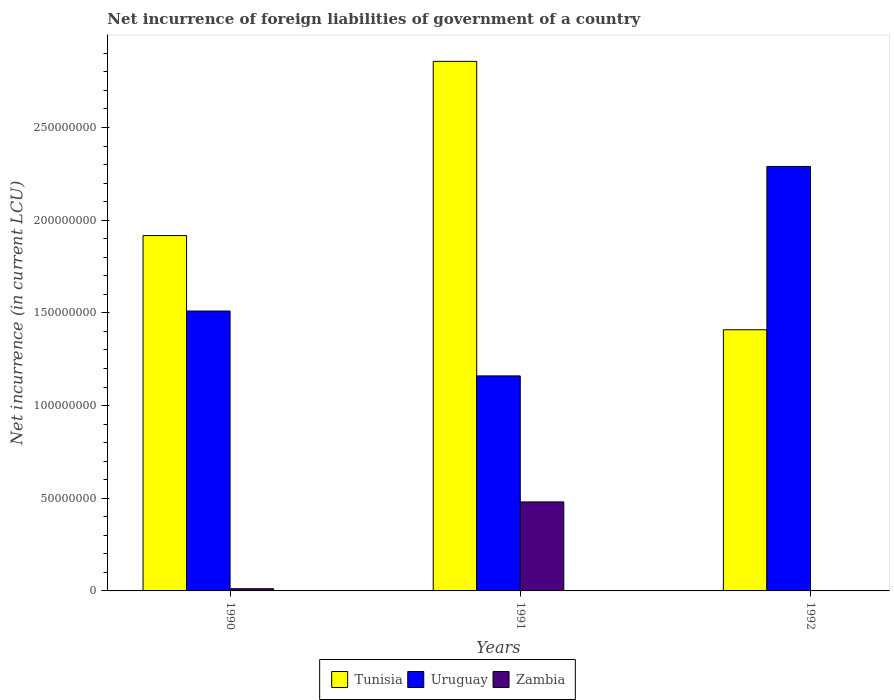How many different coloured bars are there?
Provide a succinct answer. 3. How many groups of bars are there?
Ensure brevity in your answer.  3. Are the number of bars on each tick of the X-axis equal?
Keep it short and to the point. Yes. How many bars are there on the 1st tick from the right?
Offer a terse response. 3. What is the net incurrence of foreign liabilities in Tunisia in 1992?
Provide a short and direct response. 1.41e+08. Across all years, what is the maximum net incurrence of foreign liabilities in Zambia?
Provide a succinct answer. 4.80e+07. Across all years, what is the minimum net incurrence of foreign liabilities in Uruguay?
Offer a terse response. 1.16e+08. What is the total net incurrence of foreign liabilities in Zambia in the graph?
Ensure brevity in your answer.  4.93e+07. What is the difference between the net incurrence of foreign liabilities in Tunisia in 1990 and that in 1992?
Your answer should be very brief. 5.08e+07. What is the difference between the net incurrence of foreign liabilities in Uruguay in 1992 and the net incurrence of foreign liabilities in Tunisia in 1991?
Ensure brevity in your answer.  -5.67e+07. What is the average net incurrence of foreign liabilities in Tunisia per year?
Your answer should be compact. 2.06e+08. In the year 1992, what is the difference between the net incurrence of foreign liabilities in Tunisia and net incurrence of foreign liabilities in Zambia?
Give a very brief answer. 1.41e+08. In how many years, is the net incurrence of foreign liabilities in Tunisia greater than 210000000 LCU?
Provide a short and direct response. 1. What is the ratio of the net incurrence of foreign liabilities in Uruguay in 1990 to that in 1992?
Provide a succinct answer. 0.66. What is the difference between the highest and the second highest net incurrence of foreign liabilities in Tunisia?
Make the answer very short. 9.40e+07. What is the difference between the highest and the lowest net incurrence of foreign liabilities in Uruguay?
Make the answer very short. 1.13e+08. In how many years, is the net incurrence of foreign liabilities in Tunisia greater than the average net incurrence of foreign liabilities in Tunisia taken over all years?
Provide a succinct answer. 1. Is the sum of the net incurrence of foreign liabilities in Tunisia in 1990 and 1991 greater than the maximum net incurrence of foreign liabilities in Uruguay across all years?
Offer a terse response. Yes. What does the 1st bar from the left in 1990 represents?
Give a very brief answer. Tunisia. What does the 1st bar from the right in 1992 represents?
Your answer should be compact. Zambia. How many bars are there?
Offer a terse response. 9. Are all the bars in the graph horizontal?
Make the answer very short. No. How many years are there in the graph?
Offer a terse response. 3. Are the values on the major ticks of Y-axis written in scientific E-notation?
Provide a succinct answer. No. How are the legend labels stacked?
Your response must be concise. Horizontal. What is the title of the graph?
Your response must be concise. Net incurrence of foreign liabilities of government of a country. Does "United Kingdom" appear as one of the legend labels in the graph?
Your answer should be compact. No. What is the label or title of the X-axis?
Give a very brief answer. Years. What is the label or title of the Y-axis?
Offer a terse response. Net incurrence (in current LCU). What is the Net incurrence (in current LCU) in Tunisia in 1990?
Offer a very short reply. 1.92e+08. What is the Net incurrence (in current LCU) in Uruguay in 1990?
Keep it short and to the point. 1.51e+08. What is the Net incurrence (in current LCU) in Zambia in 1990?
Your response must be concise. 1.19e+06. What is the Net incurrence (in current LCU) in Tunisia in 1991?
Offer a terse response. 2.86e+08. What is the Net incurrence (in current LCU) in Uruguay in 1991?
Your response must be concise. 1.16e+08. What is the Net incurrence (in current LCU) in Zambia in 1991?
Offer a terse response. 4.80e+07. What is the Net incurrence (in current LCU) in Tunisia in 1992?
Provide a succinct answer. 1.41e+08. What is the Net incurrence (in current LCU) of Uruguay in 1992?
Provide a succinct answer. 2.29e+08. What is the Net incurrence (in current LCU) in Zambia in 1992?
Make the answer very short. 9.39e+04. Across all years, what is the maximum Net incurrence (in current LCU) in Tunisia?
Offer a terse response. 2.86e+08. Across all years, what is the maximum Net incurrence (in current LCU) of Uruguay?
Provide a succinct answer. 2.29e+08. Across all years, what is the maximum Net incurrence (in current LCU) of Zambia?
Your answer should be compact. 4.80e+07. Across all years, what is the minimum Net incurrence (in current LCU) of Tunisia?
Your response must be concise. 1.41e+08. Across all years, what is the minimum Net incurrence (in current LCU) in Uruguay?
Give a very brief answer. 1.16e+08. Across all years, what is the minimum Net incurrence (in current LCU) of Zambia?
Your answer should be very brief. 9.39e+04. What is the total Net incurrence (in current LCU) in Tunisia in the graph?
Keep it short and to the point. 6.18e+08. What is the total Net incurrence (in current LCU) of Uruguay in the graph?
Ensure brevity in your answer.  4.96e+08. What is the total Net incurrence (in current LCU) in Zambia in the graph?
Your answer should be very brief. 4.93e+07. What is the difference between the Net incurrence (in current LCU) in Tunisia in 1990 and that in 1991?
Ensure brevity in your answer.  -9.40e+07. What is the difference between the Net incurrence (in current LCU) of Uruguay in 1990 and that in 1991?
Your answer should be very brief. 3.50e+07. What is the difference between the Net incurrence (in current LCU) of Zambia in 1990 and that in 1991?
Your answer should be very brief. -4.68e+07. What is the difference between the Net incurrence (in current LCU) of Tunisia in 1990 and that in 1992?
Offer a terse response. 5.08e+07. What is the difference between the Net incurrence (in current LCU) of Uruguay in 1990 and that in 1992?
Provide a succinct answer. -7.80e+07. What is the difference between the Net incurrence (in current LCU) of Zambia in 1990 and that in 1992?
Provide a short and direct response. 1.10e+06. What is the difference between the Net incurrence (in current LCU) of Tunisia in 1991 and that in 1992?
Give a very brief answer. 1.45e+08. What is the difference between the Net incurrence (in current LCU) of Uruguay in 1991 and that in 1992?
Your answer should be compact. -1.13e+08. What is the difference between the Net incurrence (in current LCU) in Zambia in 1991 and that in 1992?
Ensure brevity in your answer.  4.79e+07. What is the difference between the Net incurrence (in current LCU) of Tunisia in 1990 and the Net incurrence (in current LCU) of Uruguay in 1991?
Make the answer very short. 7.57e+07. What is the difference between the Net incurrence (in current LCU) in Tunisia in 1990 and the Net incurrence (in current LCU) in Zambia in 1991?
Give a very brief answer. 1.44e+08. What is the difference between the Net incurrence (in current LCU) in Uruguay in 1990 and the Net incurrence (in current LCU) in Zambia in 1991?
Provide a succinct answer. 1.03e+08. What is the difference between the Net incurrence (in current LCU) in Tunisia in 1990 and the Net incurrence (in current LCU) in Uruguay in 1992?
Your answer should be compact. -3.73e+07. What is the difference between the Net incurrence (in current LCU) of Tunisia in 1990 and the Net incurrence (in current LCU) of Zambia in 1992?
Ensure brevity in your answer.  1.92e+08. What is the difference between the Net incurrence (in current LCU) in Uruguay in 1990 and the Net incurrence (in current LCU) in Zambia in 1992?
Keep it short and to the point. 1.51e+08. What is the difference between the Net incurrence (in current LCU) in Tunisia in 1991 and the Net incurrence (in current LCU) in Uruguay in 1992?
Make the answer very short. 5.67e+07. What is the difference between the Net incurrence (in current LCU) of Tunisia in 1991 and the Net incurrence (in current LCU) of Zambia in 1992?
Offer a very short reply. 2.86e+08. What is the difference between the Net incurrence (in current LCU) of Uruguay in 1991 and the Net incurrence (in current LCU) of Zambia in 1992?
Your response must be concise. 1.16e+08. What is the average Net incurrence (in current LCU) in Tunisia per year?
Provide a succinct answer. 2.06e+08. What is the average Net incurrence (in current LCU) in Uruguay per year?
Provide a succinct answer. 1.65e+08. What is the average Net incurrence (in current LCU) in Zambia per year?
Ensure brevity in your answer.  1.64e+07. In the year 1990, what is the difference between the Net incurrence (in current LCU) of Tunisia and Net incurrence (in current LCU) of Uruguay?
Make the answer very short. 4.07e+07. In the year 1990, what is the difference between the Net incurrence (in current LCU) in Tunisia and Net incurrence (in current LCU) in Zambia?
Your answer should be very brief. 1.91e+08. In the year 1990, what is the difference between the Net incurrence (in current LCU) in Uruguay and Net incurrence (in current LCU) in Zambia?
Ensure brevity in your answer.  1.50e+08. In the year 1991, what is the difference between the Net incurrence (in current LCU) in Tunisia and Net incurrence (in current LCU) in Uruguay?
Give a very brief answer. 1.70e+08. In the year 1991, what is the difference between the Net incurrence (in current LCU) in Tunisia and Net incurrence (in current LCU) in Zambia?
Your answer should be compact. 2.38e+08. In the year 1991, what is the difference between the Net incurrence (in current LCU) of Uruguay and Net incurrence (in current LCU) of Zambia?
Your answer should be very brief. 6.80e+07. In the year 1992, what is the difference between the Net incurrence (in current LCU) in Tunisia and Net incurrence (in current LCU) in Uruguay?
Provide a succinct answer. -8.81e+07. In the year 1992, what is the difference between the Net incurrence (in current LCU) of Tunisia and Net incurrence (in current LCU) of Zambia?
Ensure brevity in your answer.  1.41e+08. In the year 1992, what is the difference between the Net incurrence (in current LCU) of Uruguay and Net incurrence (in current LCU) of Zambia?
Keep it short and to the point. 2.29e+08. What is the ratio of the Net incurrence (in current LCU) of Tunisia in 1990 to that in 1991?
Provide a succinct answer. 0.67. What is the ratio of the Net incurrence (in current LCU) in Uruguay in 1990 to that in 1991?
Offer a very short reply. 1.3. What is the ratio of the Net incurrence (in current LCU) of Zambia in 1990 to that in 1991?
Make the answer very short. 0.02. What is the ratio of the Net incurrence (in current LCU) in Tunisia in 1990 to that in 1992?
Your answer should be very brief. 1.36. What is the ratio of the Net incurrence (in current LCU) of Uruguay in 1990 to that in 1992?
Your answer should be compact. 0.66. What is the ratio of the Net incurrence (in current LCU) in Zambia in 1990 to that in 1992?
Your response must be concise. 12.67. What is the ratio of the Net incurrence (in current LCU) in Tunisia in 1991 to that in 1992?
Your response must be concise. 2.03. What is the ratio of the Net incurrence (in current LCU) of Uruguay in 1991 to that in 1992?
Your response must be concise. 0.51. What is the ratio of the Net incurrence (in current LCU) in Zambia in 1991 to that in 1992?
Your answer should be very brief. 511.33. What is the difference between the highest and the second highest Net incurrence (in current LCU) in Tunisia?
Your answer should be compact. 9.40e+07. What is the difference between the highest and the second highest Net incurrence (in current LCU) in Uruguay?
Offer a very short reply. 7.80e+07. What is the difference between the highest and the second highest Net incurrence (in current LCU) of Zambia?
Your response must be concise. 4.68e+07. What is the difference between the highest and the lowest Net incurrence (in current LCU) of Tunisia?
Offer a terse response. 1.45e+08. What is the difference between the highest and the lowest Net incurrence (in current LCU) of Uruguay?
Ensure brevity in your answer.  1.13e+08. What is the difference between the highest and the lowest Net incurrence (in current LCU) of Zambia?
Your answer should be very brief. 4.79e+07. 